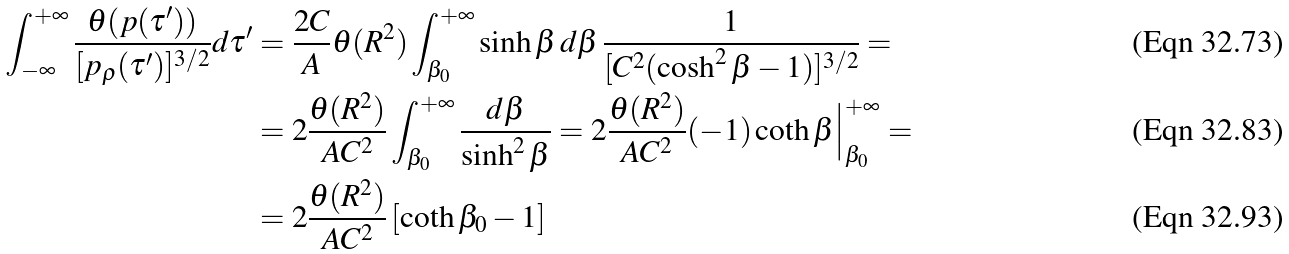Convert formula to latex. <formula><loc_0><loc_0><loc_500><loc_500>\int _ { - \infty } ^ { + \infty } \frac { \theta ( p ( \tau ^ { \prime } ) ) } { [ p _ { \rho } ( \tau ^ { \prime } ) ] ^ { 3 / 2 } } d \tau ^ { \prime } & = \frac { 2 C } { A } \theta ( R ^ { 2 } ) \int _ { \beta _ { 0 } } ^ { + \infty } \sinh \beta \, d \beta \, \frac { 1 } { [ C ^ { 2 } ( \cosh ^ { 2 } \beta - 1 ) ] ^ { 3 / 2 } } = \\ & = 2 \frac { \theta ( R ^ { 2 } ) } { A C ^ { 2 } } \int _ { \beta _ { 0 } } ^ { + \infty } \frac { d \beta } { \sinh ^ { 2 } \beta } = 2 \frac { \theta ( R ^ { 2 } ) } { A C ^ { 2 } } ( - 1 ) \coth \beta \Big | _ { \beta _ { 0 } } ^ { + \infty } = \\ & = 2 \frac { \theta ( R ^ { 2 } ) } { A C ^ { 2 } } \left [ \coth \beta _ { 0 } - 1 \right ]</formula> 